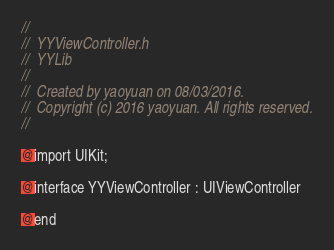Convert code to text. <code><loc_0><loc_0><loc_500><loc_500><_C_>//
//  YYViewController.h
//  YYLib
//
//  Created by yaoyuan on 08/03/2016.
//  Copyright (c) 2016 yaoyuan. All rights reserved.
//

@import UIKit;

@interface YYViewController : UIViewController

@end
</code> 